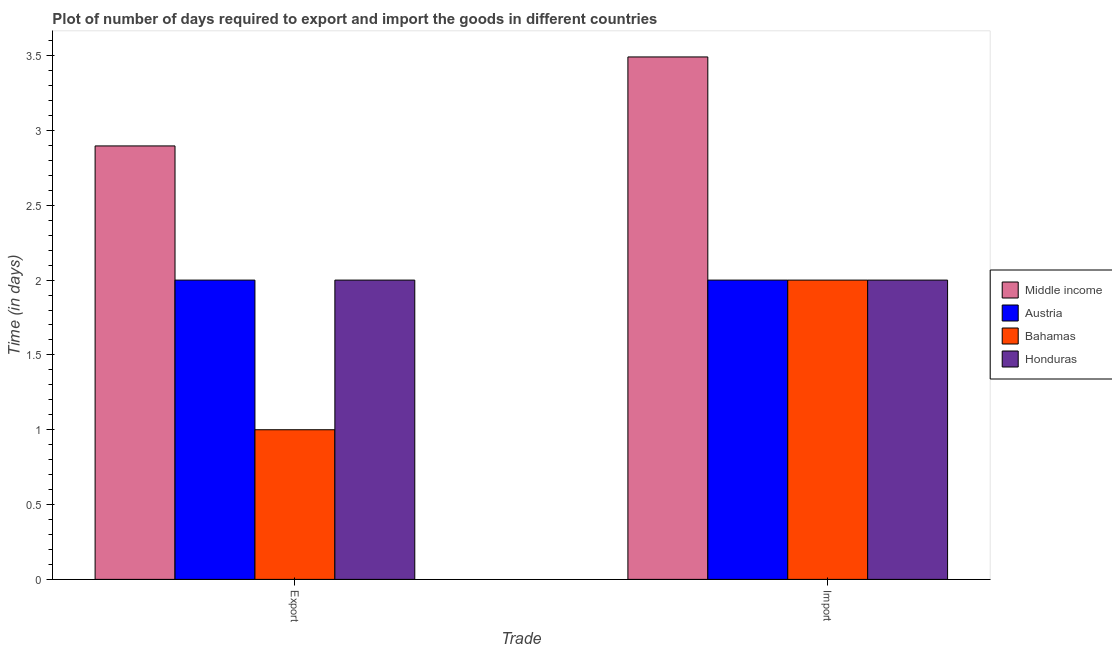How many different coloured bars are there?
Make the answer very short. 4. How many bars are there on the 1st tick from the left?
Your answer should be very brief. 4. What is the label of the 1st group of bars from the left?
Provide a short and direct response. Export. What is the time required to export in Austria?
Give a very brief answer. 2. Across all countries, what is the maximum time required to import?
Your answer should be compact. 3.49. Across all countries, what is the minimum time required to import?
Provide a short and direct response. 2. In which country was the time required to export minimum?
Provide a succinct answer. Bahamas. What is the total time required to export in the graph?
Give a very brief answer. 7.9. What is the difference between the time required to export in Austria and that in Bahamas?
Provide a succinct answer. 1. What is the difference between the time required to import in Honduras and the time required to export in Middle income?
Offer a terse response. -0.9. What is the average time required to export per country?
Make the answer very short. 1.97. What is the difference between the time required to export and time required to import in Bahamas?
Ensure brevity in your answer.  -1. In how many countries, is the time required to import greater than 2.2 days?
Ensure brevity in your answer.  1. In how many countries, is the time required to import greater than the average time required to import taken over all countries?
Keep it short and to the point. 1. What does the 3rd bar from the left in Export represents?
Offer a terse response. Bahamas. What does the 3rd bar from the right in Import represents?
Your response must be concise. Austria. Are all the bars in the graph horizontal?
Make the answer very short. No. How many countries are there in the graph?
Keep it short and to the point. 4. What is the difference between two consecutive major ticks on the Y-axis?
Keep it short and to the point. 0.5. Are the values on the major ticks of Y-axis written in scientific E-notation?
Offer a very short reply. No. Does the graph contain grids?
Give a very brief answer. No. Where does the legend appear in the graph?
Offer a very short reply. Center right. How are the legend labels stacked?
Your answer should be compact. Vertical. What is the title of the graph?
Your answer should be compact. Plot of number of days required to export and import the goods in different countries. Does "New Zealand" appear as one of the legend labels in the graph?
Keep it short and to the point. No. What is the label or title of the X-axis?
Ensure brevity in your answer.  Trade. What is the label or title of the Y-axis?
Your answer should be compact. Time (in days). What is the Time (in days) in Middle income in Export?
Your response must be concise. 2.9. What is the Time (in days) in Middle income in Import?
Your answer should be very brief. 3.49. What is the Time (in days) of Austria in Import?
Provide a succinct answer. 2. What is the Time (in days) of Honduras in Import?
Offer a terse response. 2. Across all Trade, what is the maximum Time (in days) of Middle income?
Make the answer very short. 3.49. Across all Trade, what is the maximum Time (in days) in Honduras?
Your response must be concise. 2. Across all Trade, what is the minimum Time (in days) in Middle income?
Ensure brevity in your answer.  2.9. Across all Trade, what is the minimum Time (in days) in Bahamas?
Offer a very short reply. 1. Across all Trade, what is the minimum Time (in days) in Honduras?
Your answer should be compact. 2. What is the total Time (in days) in Middle income in the graph?
Keep it short and to the point. 6.39. What is the total Time (in days) of Austria in the graph?
Offer a terse response. 4. What is the total Time (in days) of Honduras in the graph?
Make the answer very short. 4. What is the difference between the Time (in days) of Middle income in Export and that in Import?
Keep it short and to the point. -0.59. What is the difference between the Time (in days) in Middle income in Export and the Time (in days) in Austria in Import?
Ensure brevity in your answer.  0.9. What is the difference between the Time (in days) in Middle income in Export and the Time (in days) in Bahamas in Import?
Your answer should be very brief. 0.9. What is the difference between the Time (in days) of Middle income in Export and the Time (in days) of Honduras in Import?
Ensure brevity in your answer.  0.9. What is the difference between the Time (in days) in Austria in Export and the Time (in days) in Honduras in Import?
Your answer should be very brief. 0. What is the average Time (in days) in Middle income per Trade?
Make the answer very short. 3.19. What is the average Time (in days) of Austria per Trade?
Offer a terse response. 2. What is the average Time (in days) in Bahamas per Trade?
Give a very brief answer. 1.5. What is the average Time (in days) of Honduras per Trade?
Your response must be concise. 2. What is the difference between the Time (in days) of Middle income and Time (in days) of Austria in Export?
Provide a succinct answer. 0.9. What is the difference between the Time (in days) in Middle income and Time (in days) in Bahamas in Export?
Your response must be concise. 1.9. What is the difference between the Time (in days) in Middle income and Time (in days) in Honduras in Export?
Provide a succinct answer. 0.9. What is the difference between the Time (in days) of Austria and Time (in days) of Honduras in Export?
Make the answer very short. 0. What is the difference between the Time (in days) in Middle income and Time (in days) in Austria in Import?
Give a very brief answer. 1.49. What is the difference between the Time (in days) in Middle income and Time (in days) in Bahamas in Import?
Your response must be concise. 1.49. What is the difference between the Time (in days) in Middle income and Time (in days) in Honduras in Import?
Make the answer very short. 1.49. What is the difference between the Time (in days) of Austria and Time (in days) of Bahamas in Import?
Offer a terse response. 0. What is the ratio of the Time (in days) in Middle income in Export to that in Import?
Your answer should be compact. 0.83. What is the ratio of the Time (in days) in Austria in Export to that in Import?
Your response must be concise. 1. What is the ratio of the Time (in days) in Bahamas in Export to that in Import?
Give a very brief answer. 0.5. What is the difference between the highest and the second highest Time (in days) of Middle income?
Your answer should be compact. 0.59. What is the difference between the highest and the second highest Time (in days) of Bahamas?
Offer a terse response. 1. What is the difference between the highest and the lowest Time (in days) of Middle income?
Your response must be concise. 0.59. What is the difference between the highest and the lowest Time (in days) in Austria?
Make the answer very short. 0. What is the difference between the highest and the lowest Time (in days) in Honduras?
Your answer should be very brief. 0. 